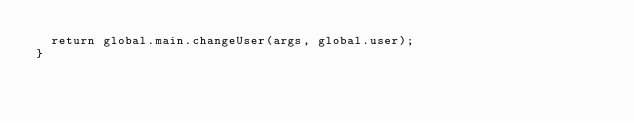<code> <loc_0><loc_0><loc_500><loc_500><_JavaScript_>  return global.main.changeUser(args, global.user);
}</code> 